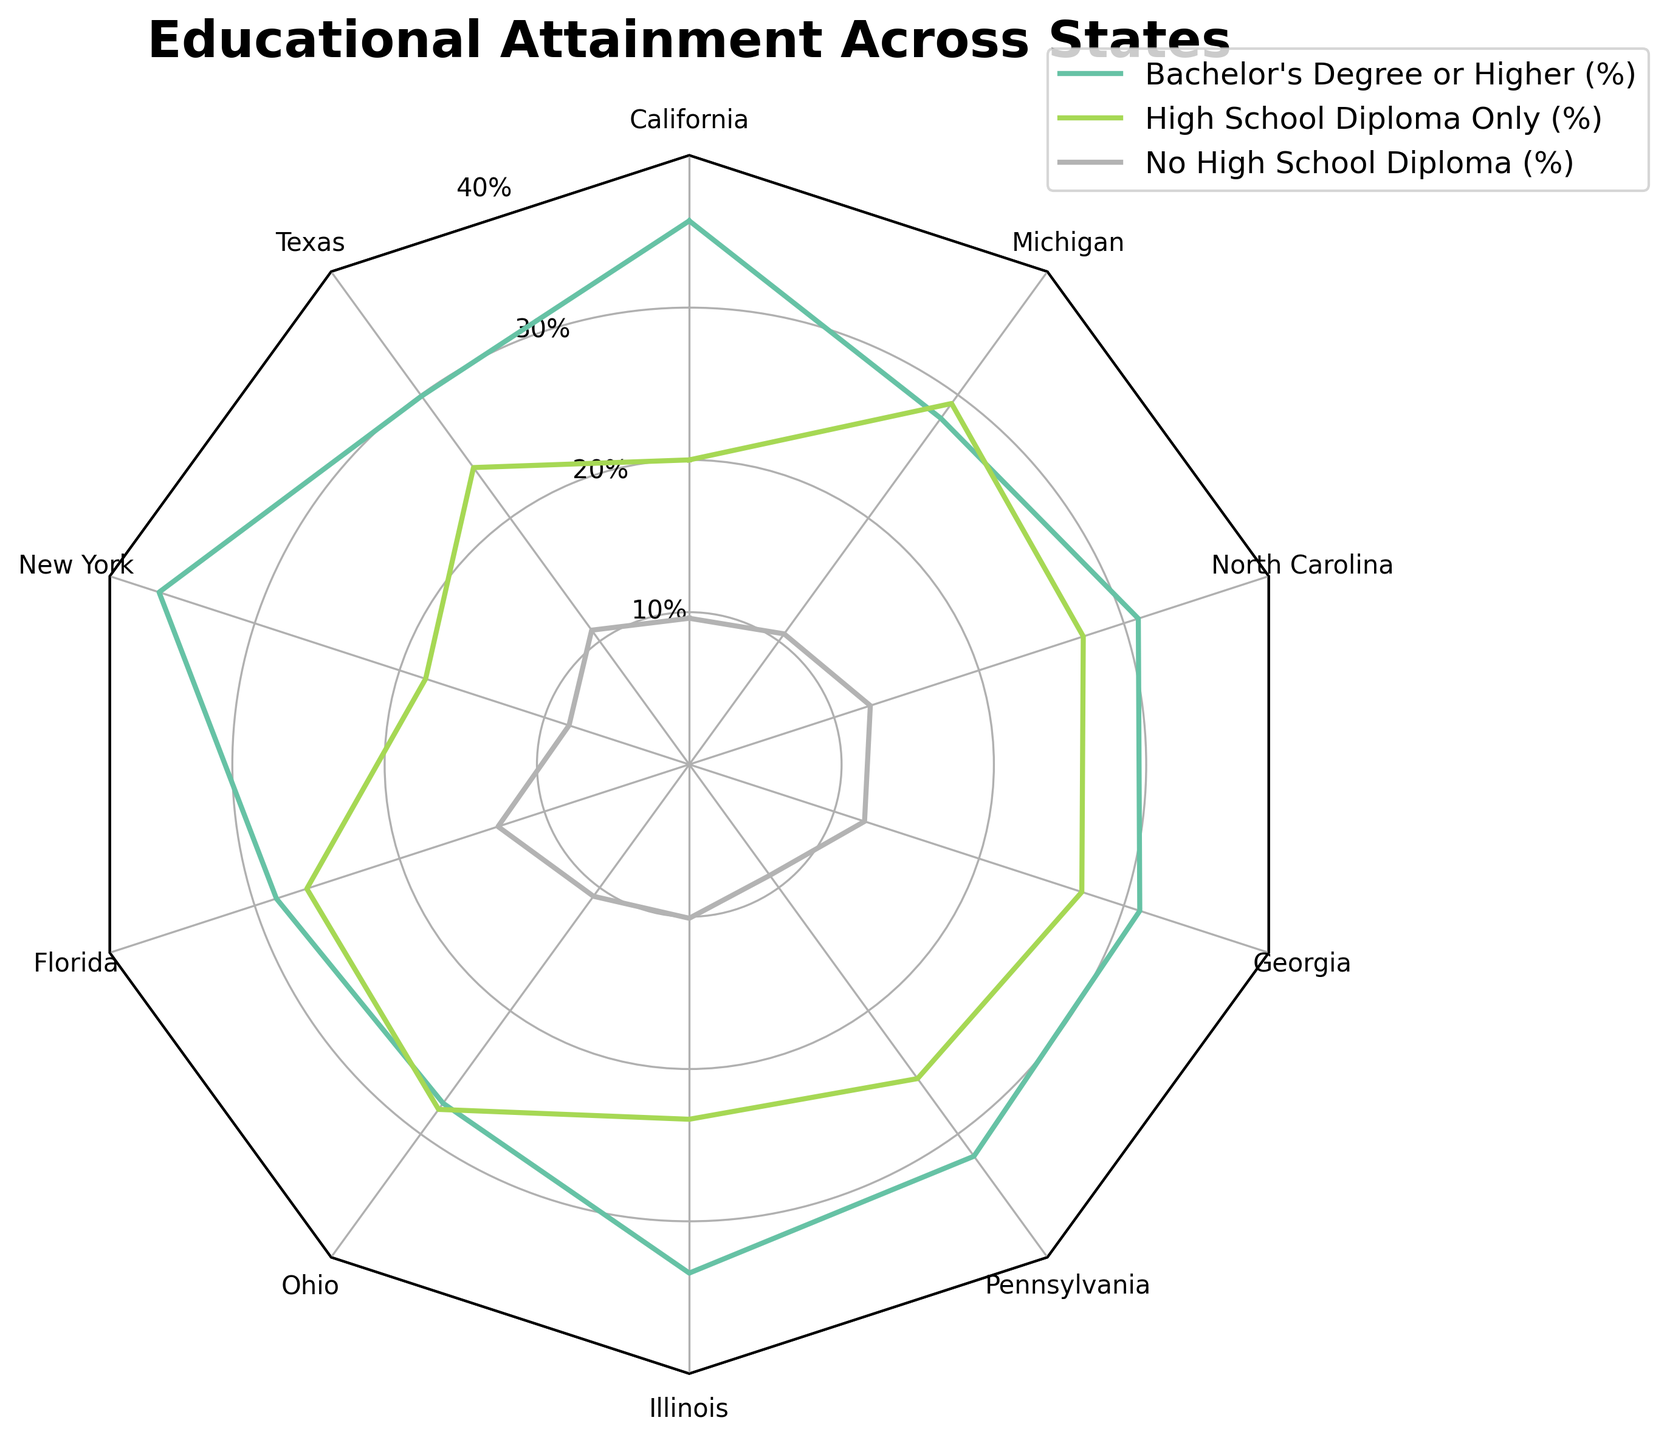What's the title of the figure? The title is located at the top of the figure and is usually in a larger font size than the other text.
Answer: Educational Attainment Across States How many states are represented in the radar chart? Each vertex of the radar chart represents a different state. By counting the vertices, we can determine the number of states.
Answer: 10 What is the percentage value of Bachelor's Degree or Higher for New York? Locate New York on the radar chart, then find the corresponding value along the Bachelor's Degree or Higher line.
Answer: 36.6% Which state has the highest percentage of people with a High School Diploma only? Compare the High School Diploma only values for all states and identify the highest one.
Answer: Michigan Are there any states with a No High School Diploma percentage greater than 12%? Check the No High School Diploma line for all states and identify any values greater than 12%.
Answer: Yes, Florida, Georgia, and North Carolina What is the average percentage of High School Diploma Only across all states? Sum the High School Diploma Only percentages for all states and divide by the number of states (10).
Answer: 24.51% Which state has the lowest percentage of Bachelor's Degree or Higher? Compare the Bachelor's Degree or Higher values for all states and identify the lowest one.
Answer: Ohio Rank the states based on their percentage of No High School Diploma from highest to lowest. List the states in descending order based on their No High School Diploma percentages.
Answer: Florida, Georgia, North Carolina, Texas, Ohio, Michigan, Illinois, California, Pennsylvania, New York What is the total percentage of Bachelor's Degree or Higher for California, New York, and Pennsylvania combined? Sum the Bachelor's Degree or Higher percentages for California, New York, and Pennsylvania.
Answer: 104.1% Is there any correlation visible between the percentages of High School Diploma Only and No High School Diploma? Observe the radar chart to see if states with higher percentages of High School Diploma Only tend to have higher or lower percentages of No High School Diploma.
Answer: No clear correlation Which educational attainment category shows the most variation among the states? Observe the spread of the values for each category across the states; the one with the widest range shows the most variation.
Answer: High School Diploma Only 